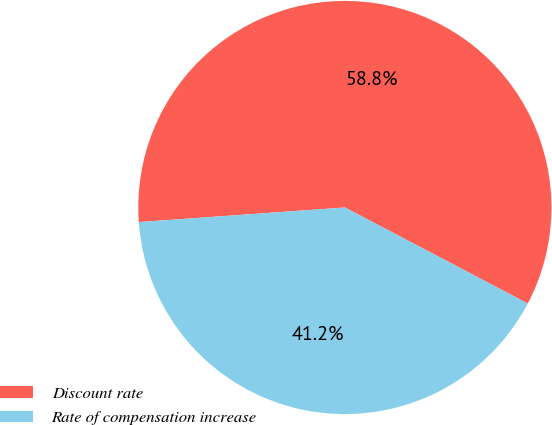Convert chart. <chart><loc_0><loc_0><loc_500><loc_500><pie_chart><fcel>Discount rate<fcel>Rate of compensation increase<nl><fcel>58.82%<fcel>41.18%<nl></chart> 